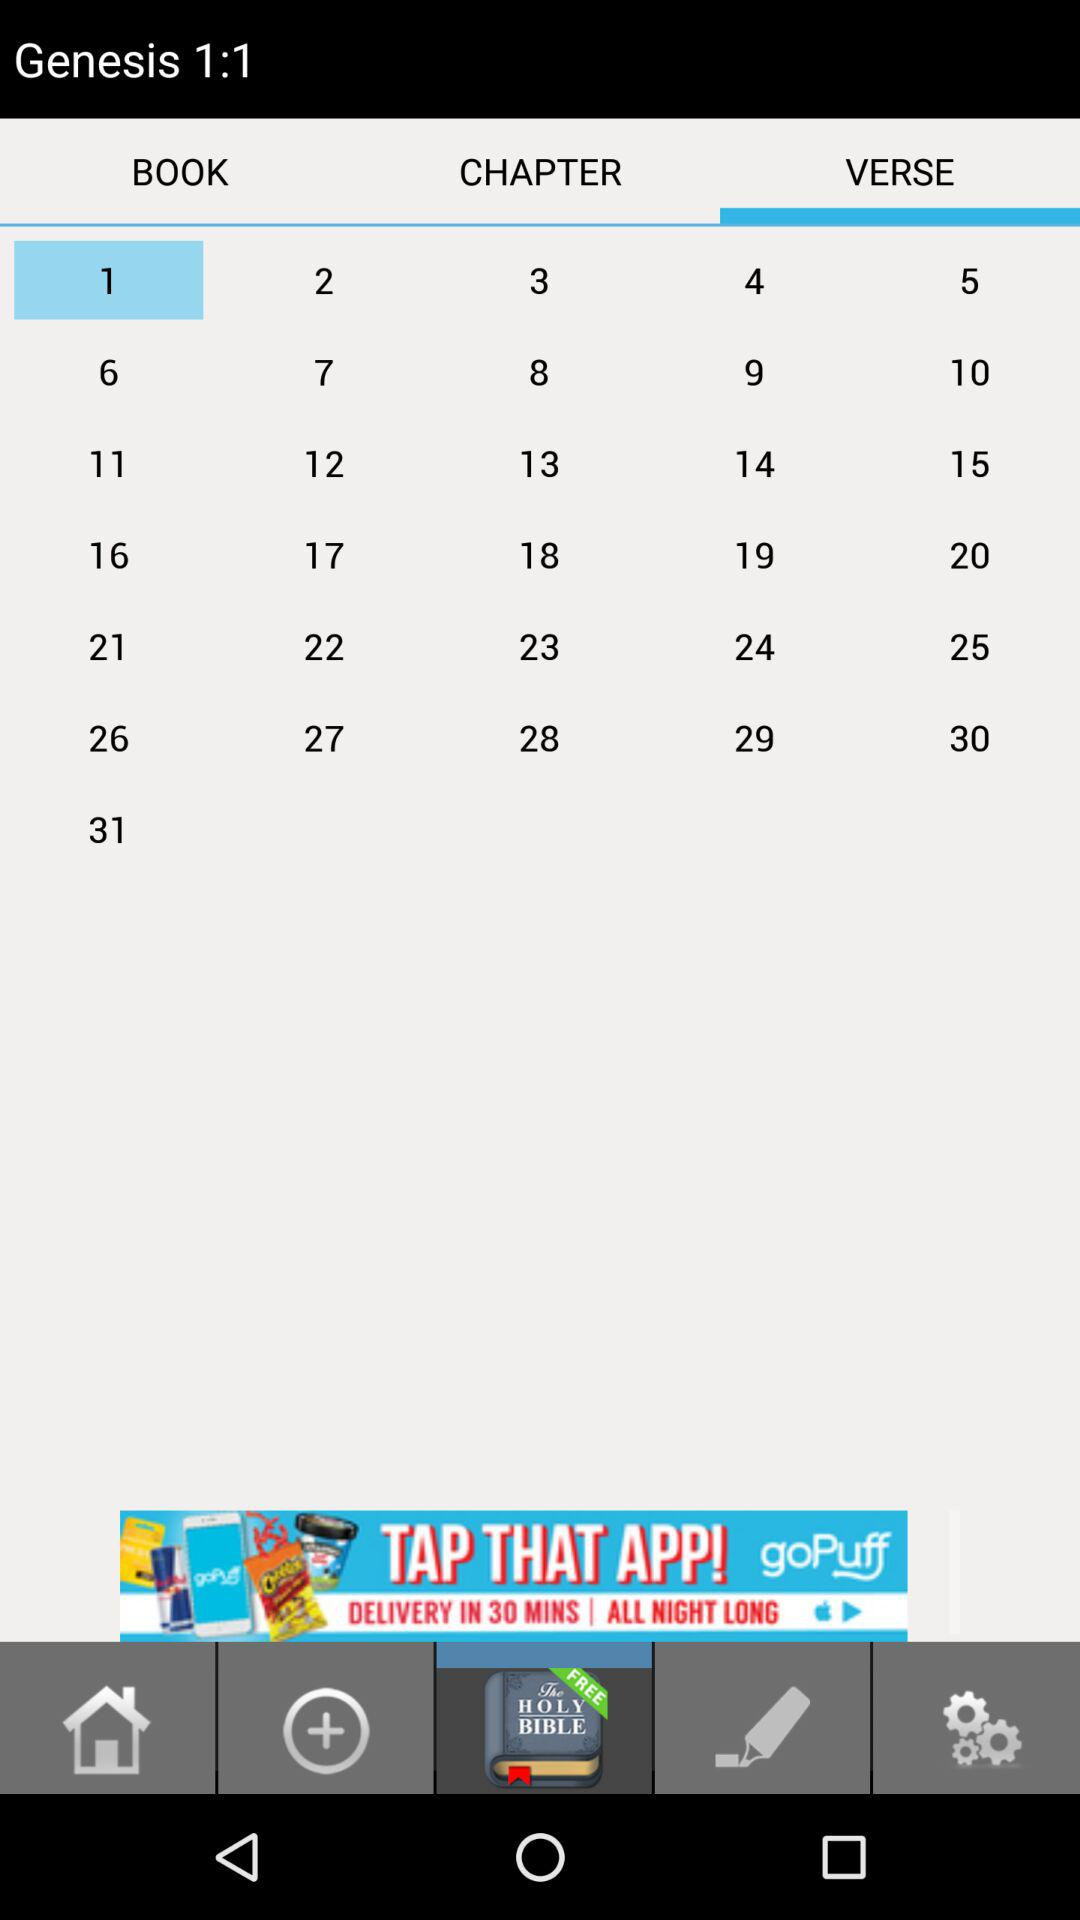What is the selected verse? The selected verse is 1. 